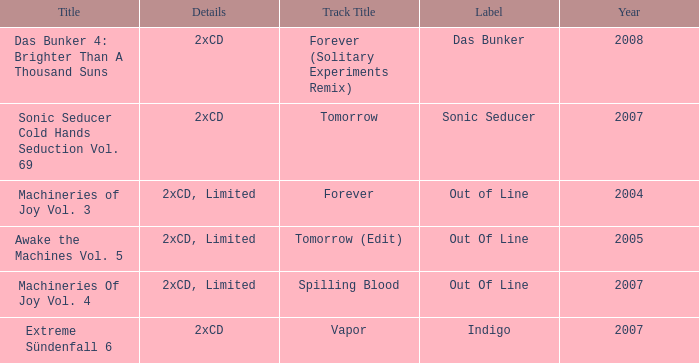Which details has the out of line label and the year of 2005? 2xCD, Limited. 